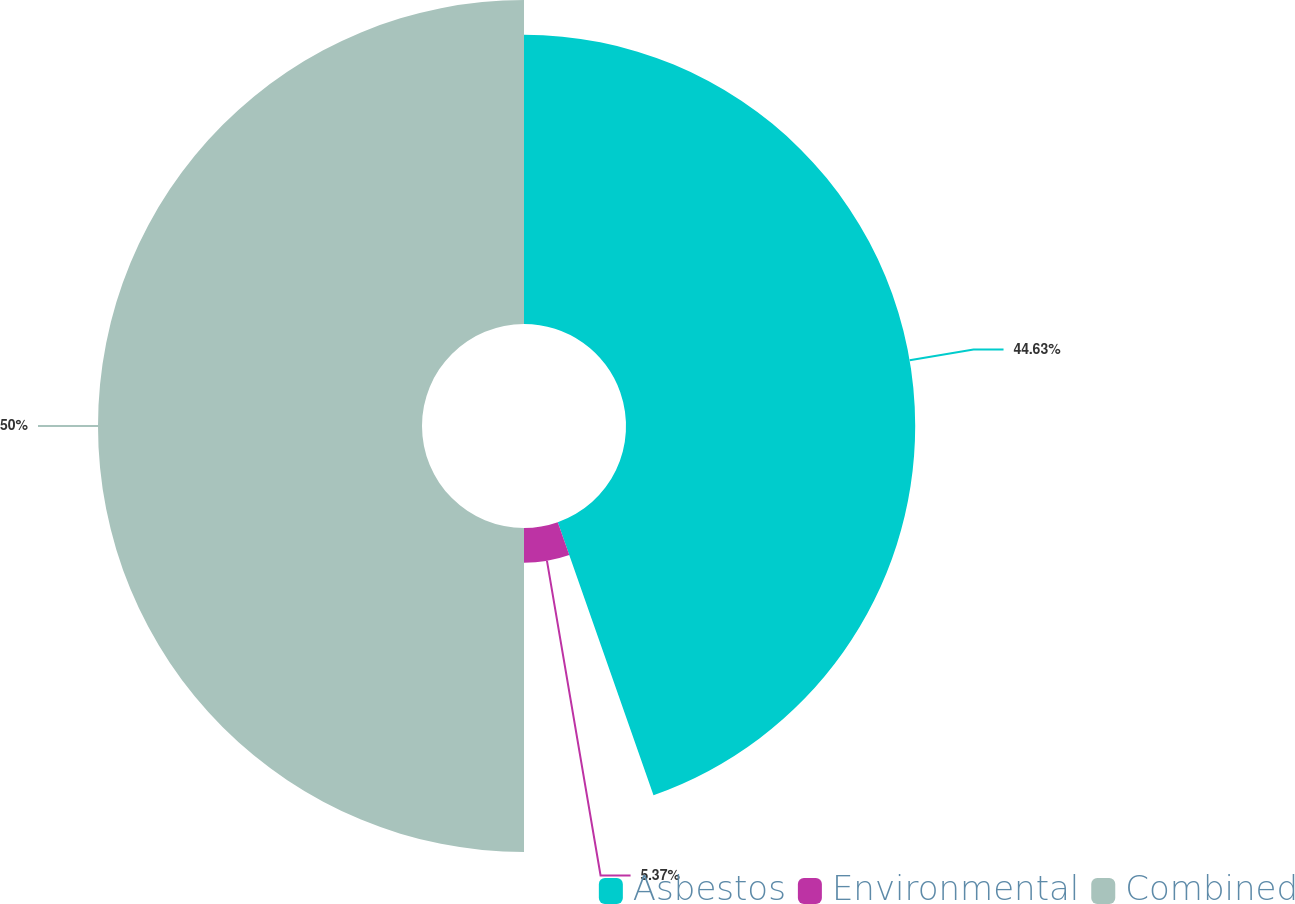Convert chart to OTSL. <chart><loc_0><loc_0><loc_500><loc_500><pie_chart><fcel>Asbestos<fcel>Environmental<fcel>Combined<nl><fcel>44.63%<fcel>5.37%<fcel>50.0%<nl></chart> 